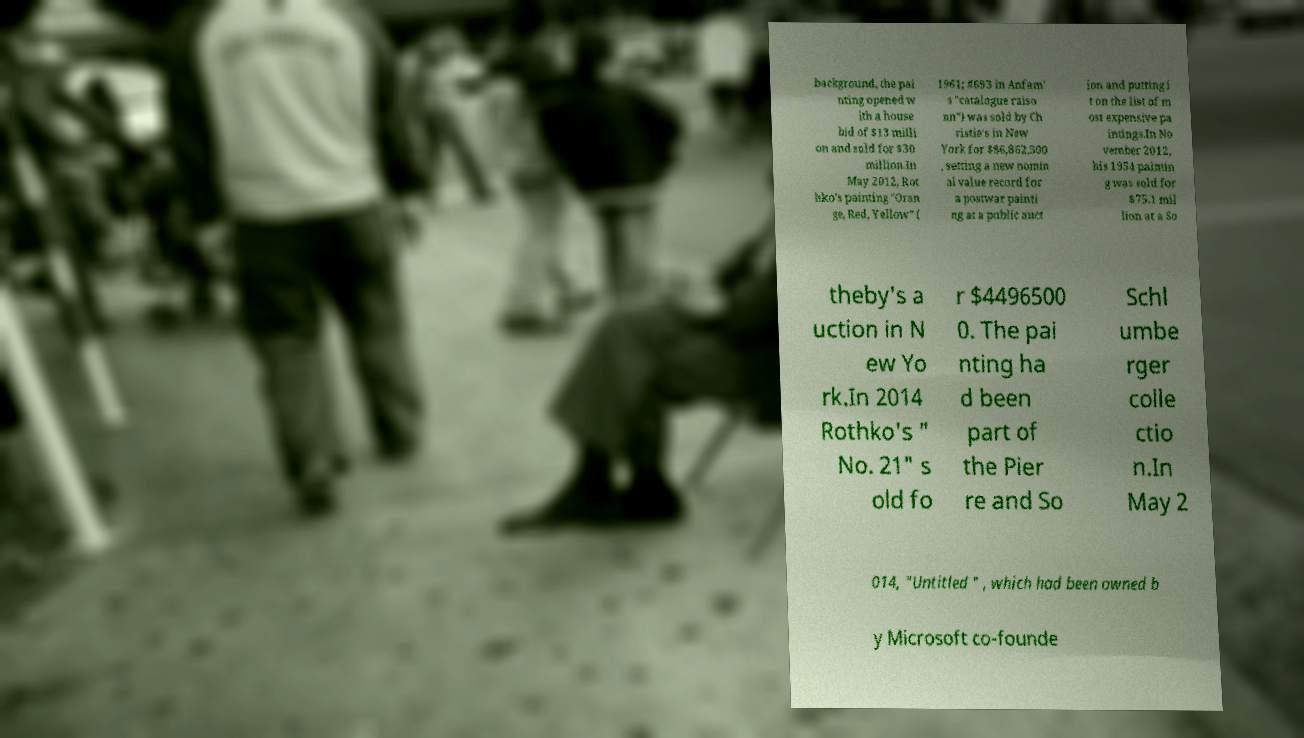What messages or text are displayed in this image? I need them in a readable, typed format. background, the pai nting opened w ith a house bid of $13 milli on and sold for $30 million.In May 2012, Rot hko's painting "Oran ge, Red, Yellow" ( 1961; #693 in Anfam' s "catalogue raiso nn") was sold by Ch ristie's in New York for $86,862,500 , setting a new nomin al value record for a postwar painti ng at a public auct ion and putting i t on the list of m ost expensive pa intings.In No vember 2012, his 1954 paintin g was sold for $75.1 mil lion at a So theby's a uction in N ew Yo rk.In 2014 Rothko's " No. 21" s old fo r $4496500 0. The pai nting ha d been part of the Pier re and So Schl umbe rger colle ctio n.In May 2 014, "Untitled " , which had been owned b y Microsoft co-founde 